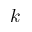Convert formula to latex. <formula><loc_0><loc_0><loc_500><loc_500>k</formula> 